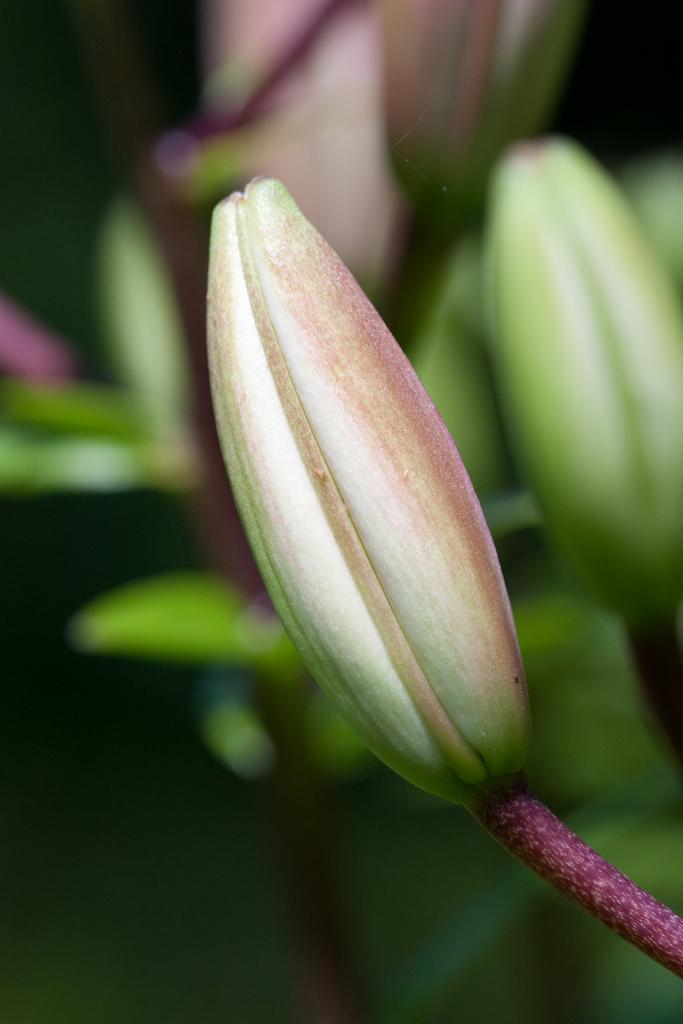What is the main subject of the image? There is a flower in the image. Can you describe the background of the image? The background of the image is blurry. What type of field can be seen in the image? There is no field present in the image; it features a flower with a blurry background. What might be causing the blurriness in the throat of the person taking the picture? There is no person present in the image, and the blurriness is a characteristic of the background, not related to a person's throat. 